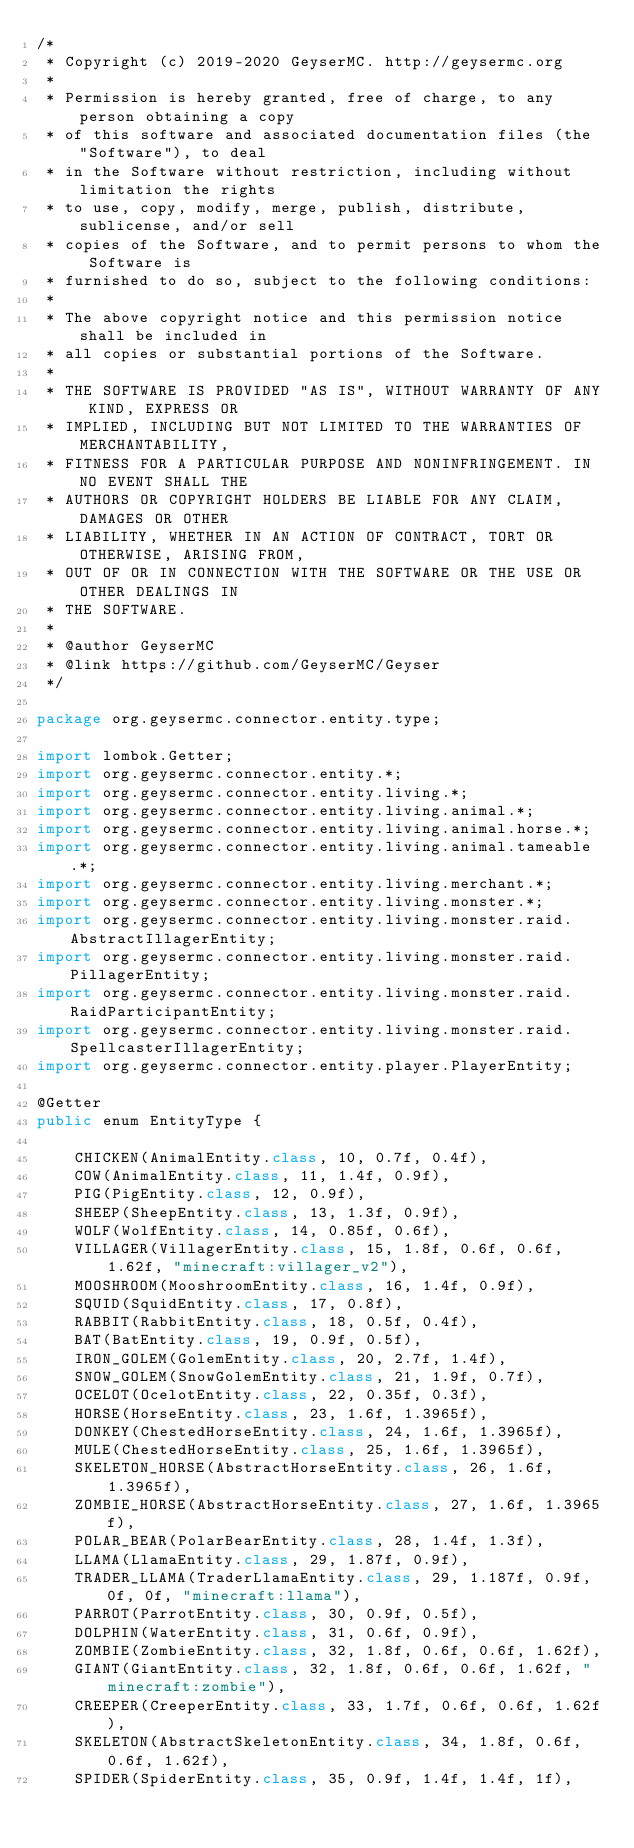Convert code to text. <code><loc_0><loc_0><loc_500><loc_500><_Java_>/*
 * Copyright (c) 2019-2020 GeyserMC. http://geysermc.org
 *
 * Permission is hereby granted, free of charge, to any person obtaining a copy
 * of this software and associated documentation files (the "Software"), to deal
 * in the Software without restriction, including without limitation the rights
 * to use, copy, modify, merge, publish, distribute, sublicense, and/or sell
 * copies of the Software, and to permit persons to whom the Software is
 * furnished to do so, subject to the following conditions:
 *
 * The above copyright notice and this permission notice shall be included in
 * all copies or substantial portions of the Software.
 *
 * THE SOFTWARE IS PROVIDED "AS IS", WITHOUT WARRANTY OF ANY KIND, EXPRESS OR
 * IMPLIED, INCLUDING BUT NOT LIMITED TO THE WARRANTIES OF MERCHANTABILITY,
 * FITNESS FOR A PARTICULAR PURPOSE AND NONINFRINGEMENT. IN NO EVENT SHALL THE
 * AUTHORS OR COPYRIGHT HOLDERS BE LIABLE FOR ANY CLAIM, DAMAGES OR OTHER
 * LIABILITY, WHETHER IN AN ACTION OF CONTRACT, TORT OR OTHERWISE, ARISING FROM,
 * OUT OF OR IN CONNECTION WITH THE SOFTWARE OR THE USE OR OTHER DEALINGS IN
 * THE SOFTWARE.
 *
 * @author GeyserMC
 * @link https://github.com/GeyserMC/Geyser
 */

package org.geysermc.connector.entity.type;

import lombok.Getter;
import org.geysermc.connector.entity.*;
import org.geysermc.connector.entity.living.*;
import org.geysermc.connector.entity.living.animal.*;
import org.geysermc.connector.entity.living.animal.horse.*;
import org.geysermc.connector.entity.living.animal.tameable.*;
import org.geysermc.connector.entity.living.merchant.*;
import org.geysermc.connector.entity.living.monster.*;
import org.geysermc.connector.entity.living.monster.raid.AbstractIllagerEntity;
import org.geysermc.connector.entity.living.monster.raid.PillagerEntity;
import org.geysermc.connector.entity.living.monster.raid.RaidParticipantEntity;
import org.geysermc.connector.entity.living.monster.raid.SpellcasterIllagerEntity;
import org.geysermc.connector.entity.player.PlayerEntity;

@Getter
public enum EntityType {

    CHICKEN(AnimalEntity.class, 10, 0.7f, 0.4f),
    COW(AnimalEntity.class, 11, 1.4f, 0.9f),
    PIG(PigEntity.class, 12, 0.9f),
    SHEEP(SheepEntity.class, 13, 1.3f, 0.9f),
    WOLF(WolfEntity.class, 14, 0.85f, 0.6f),
    VILLAGER(VillagerEntity.class, 15, 1.8f, 0.6f, 0.6f, 1.62f, "minecraft:villager_v2"),
    MOOSHROOM(MooshroomEntity.class, 16, 1.4f, 0.9f),
    SQUID(SquidEntity.class, 17, 0.8f),
    RABBIT(RabbitEntity.class, 18, 0.5f, 0.4f),
    BAT(BatEntity.class, 19, 0.9f, 0.5f),
    IRON_GOLEM(GolemEntity.class, 20, 2.7f, 1.4f),
    SNOW_GOLEM(SnowGolemEntity.class, 21, 1.9f, 0.7f),
    OCELOT(OcelotEntity.class, 22, 0.35f, 0.3f),
    HORSE(HorseEntity.class, 23, 1.6f, 1.3965f),
    DONKEY(ChestedHorseEntity.class, 24, 1.6f, 1.3965f),
    MULE(ChestedHorseEntity.class, 25, 1.6f, 1.3965f),
    SKELETON_HORSE(AbstractHorseEntity.class, 26, 1.6f, 1.3965f),
    ZOMBIE_HORSE(AbstractHorseEntity.class, 27, 1.6f, 1.3965f),
    POLAR_BEAR(PolarBearEntity.class, 28, 1.4f, 1.3f),
    LLAMA(LlamaEntity.class, 29, 1.87f, 0.9f),
    TRADER_LLAMA(TraderLlamaEntity.class, 29, 1.187f, 0.9f, 0f, 0f, "minecraft:llama"),
    PARROT(ParrotEntity.class, 30, 0.9f, 0.5f),
    DOLPHIN(WaterEntity.class, 31, 0.6f, 0.9f),
    ZOMBIE(ZombieEntity.class, 32, 1.8f, 0.6f, 0.6f, 1.62f),
    GIANT(GiantEntity.class, 32, 1.8f, 0.6f, 0.6f, 1.62f, "minecraft:zombie"),
    CREEPER(CreeperEntity.class, 33, 1.7f, 0.6f, 0.6f, 1.62f),
    SKELETON(AbstractSkeletonEntity.class, 34, 1.8f, 0.6f, 0.6f, 1.62f),
    SPIDER(SpiderEntity.class, 35, 0.9f, 1.4f, 1.4f, 1f),</code> 